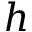Convert formula to latex. <formula><loc_0><loc_0><loc_500><loc_500>h</formula> 